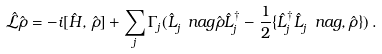<formula> <loc_0><loc_0><loc_500><loc_500>\hat { \mathcal { L } } \hat { \rho } = - i [ \hat { H } , \, \hat { \rho } ] + \sum _ { j } \Gamma _ { j } ( \hat { L } _ { j } ^ { \ } n a g \hat { \rho } \hat { L } _ { j } ^ { \dag } - \frac { 1 } { 2 } \{ \hat { L } _ { j } ^ { \dag } \hat { L } _ { j } ^ { \ } n a g , \hat { \rho } \} ) \, .</formula> 